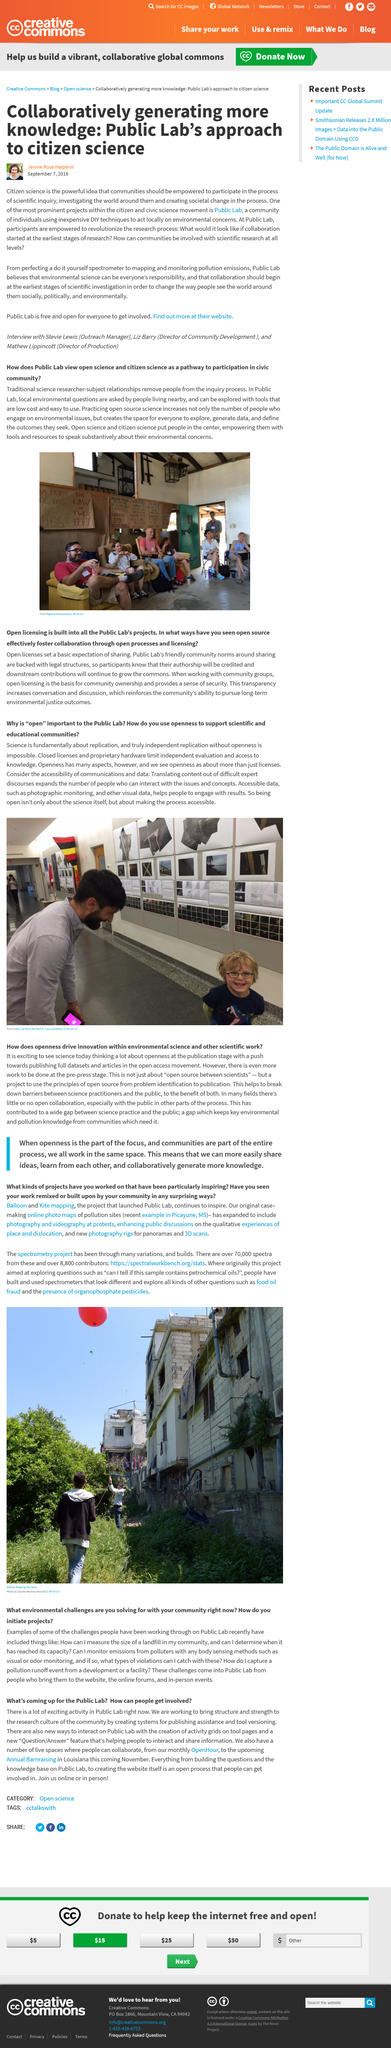Give some essential details in this illustration. Science is primarily about replication, as it is essential to the scientific method and the establishment of scientific knowledge. Through the practice of open source science, we aim to increase the number of individuals engaged in environmental issues and create a space for all to explore, generate data, and define the outcomes they seek. The picture depicts a Public Lab, where local individuals can engage in discussions regarding environmental concerns and contribute to the validation of related studies. The photo was taken in a Public Lab. Jennie Rose Halperin is the author of the text. 